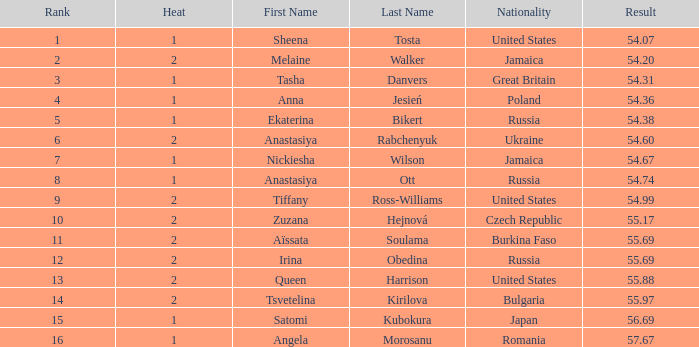Which Nationality has a Heat smaller than 2, and a Rank of 15? Japan. Could you parse the entire table? {'header': ['Rank', 'Heat', 'First Name', 'Last Name', 'Nationality', 'Result'], 'rows': [['1', '1', 'Sheena', 'Tosta', 'United States', '54.07'], ['2', '2', 'Melaine', 'Walker', 'Jamaica', '54.20'], ['3', '1', 'Tasha', 'Danvers', 'Great Britain', '54.31'], ['4', '1', 'Anna', 'Jesień', 'Poland', '54.36'], ['5', '1', 'Ekaterina', 'Bikert', 'Russia', '54.38'], ['6', '2', 'Anastasiya', 'Rabchenyuk', 'Ukraine', '54.60'], ['7', '1', 'Nickiesha', 'Wilson', 'Jamaica', '54.67'], ['8', '1', 'Anastasiya', 'Ott', 'Russia', '54.74'], ['9', '2', 'Tiffany', 'Ross-Williams', 'United States', '54.99'], ['10', '2', 'Zuzana', 'Hejnová', 'Czech Republic', '55.17'], ['11', '2', 'Aïssata', 'Soulama', 'Burkina Faso', '55.69'], ['12', '2', 'Irina', 'Obedina', 'Russia', '55.69'], ['13', '2', 'Queen', 'Harrison', 'United States', '55.88'], ['14', '2', 'Tsvetelina', 'Kirilova', 'Bulgaria', '55.97'], ['15', '1', 'Satomi', 'Kubokura', 'Japan', '56.69'], ['16', '1', 'Angela', 'Morosanu', 'Romania', '57.67']]} 